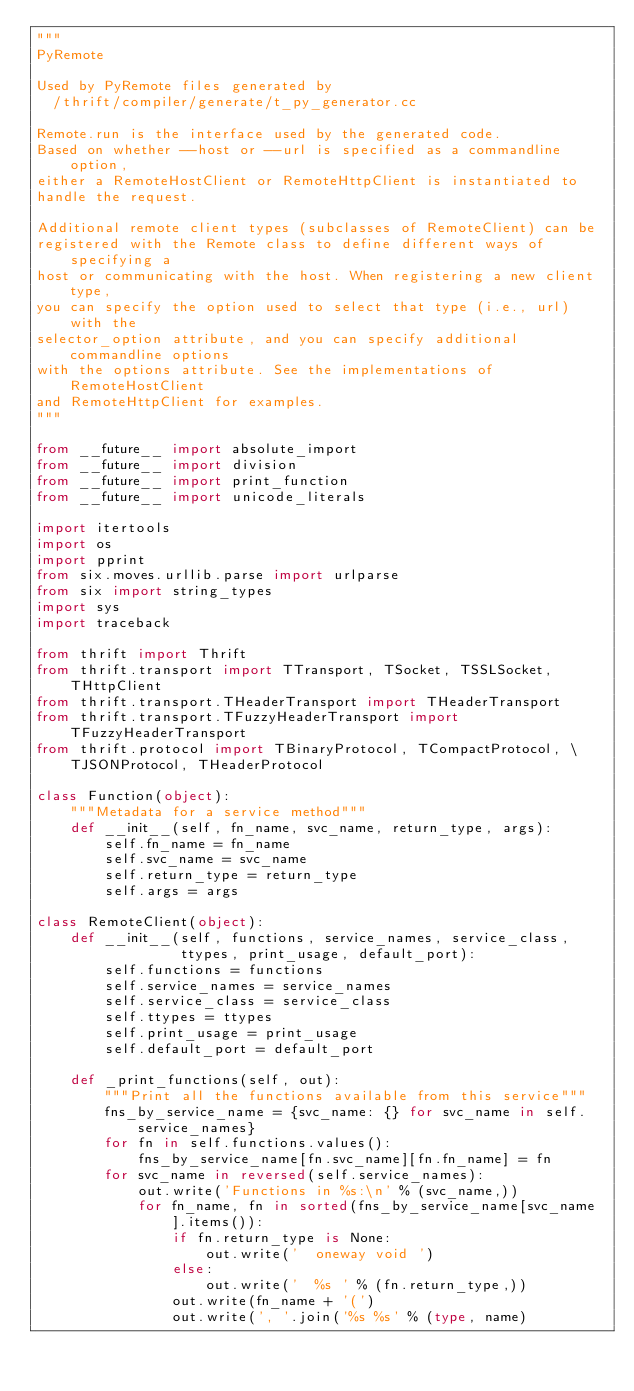<code> <loc_0><loc_0><loc_500><loc_500><_Python_>"""
PyRemote

Used by PyRemote files generated by
  /thrift/compiler/generate/t_py_generator.cc

Remote.run is the interface used by the generated code.
Based on whether --host or --url is specified as a commandline option,
either a RemoteHostClient or RemoteHttpClient is instantiated to
handle the request.

Additional remote client types (subclasses of RemoteClient) can be
registered with the Remote class to define different ways of specifying a
host or communicating with the host. When registering a new client type,
you can specify the option used to select that type (i.e., url) with the
selector_option attribute, and you can specify additional commandline options
with the options attribute. See the implementations of RemoteHostClient
and RemoteHttpClient for examples.
"""

from __future__ import absolute_import
from __future__ import division
from __future__ import print_function
from __future__ import unicode_literals

import itertools
import os
import pprint
from six.moves.urllib.parse import urlparse
from six import string_types
import sys
import traceback

from thrift import Thrift
from thrift.transport import TTransport, TSocket, TSSLSocket, THttpClient
from thrift.transport.THeaderTransport import THeaderTransport
from thrift.transport.TFuzzyHeaderTransport import TFuzzyHeaderTransport
from thrift.protocol import TBinaryProtocol, TCompactProtocol, \
    TJSONProtocol, THeaderProtocol

class Function(object):
    """Metadata for a service method"""
    def __init__(self, fn_name, svc_name, return_type, args):
        self.fn_name = fn_name
        self.svc_name = svc_name
        self.return_type = return_type
        self.args = args

class RemoteClient(object):
    def __init__(self, functions, service_names, service_class,
                 ttypes, print_usage, default_port):
        self.functions = functions
        self.service_names = service_names
        self.service_class = service_class
        self.ttypes = ttypes
        self.print_usage = print_usage
        self.default_port = default_port

    def _print_functions(self, out):
        """Print all the functions available from this service"""
        fns_by_service_name = {svc_name: {} for svc_name in self.service_names}
        for fn in self.functions.values():
            fns_by_service_name[fn.svc_name][fn.fn_name] = fn
        for svc_name in reversed(self.service_names):
            out.write('Functions in %s:\n' % (svc_name,))
            for fn_name, fn in sorted(fns_by_service_name[svc_name].items()):
                if fn.return_type is None:
                    out.write('  oneway void ')
                else:
                    out.write('  %s ' % (fn.return_type,))
                out.write(fn_name + '(')
                out.write(', '.join('%s %s' % (type, name)</code> 